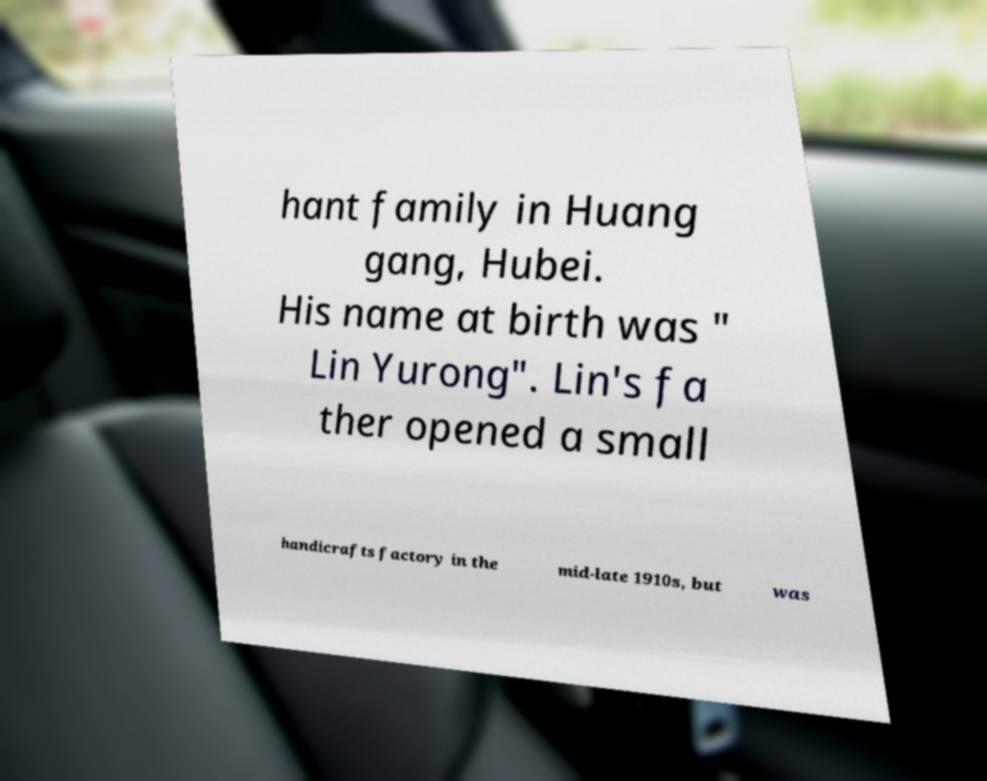Please read and relay the text visible in this image. What does it say? hant family in Huang gang, Hubei. His name at birth was " Lin Yurong". Lin's fa ther opened a small handicrafts factory in the mid-late 1910s, but was 